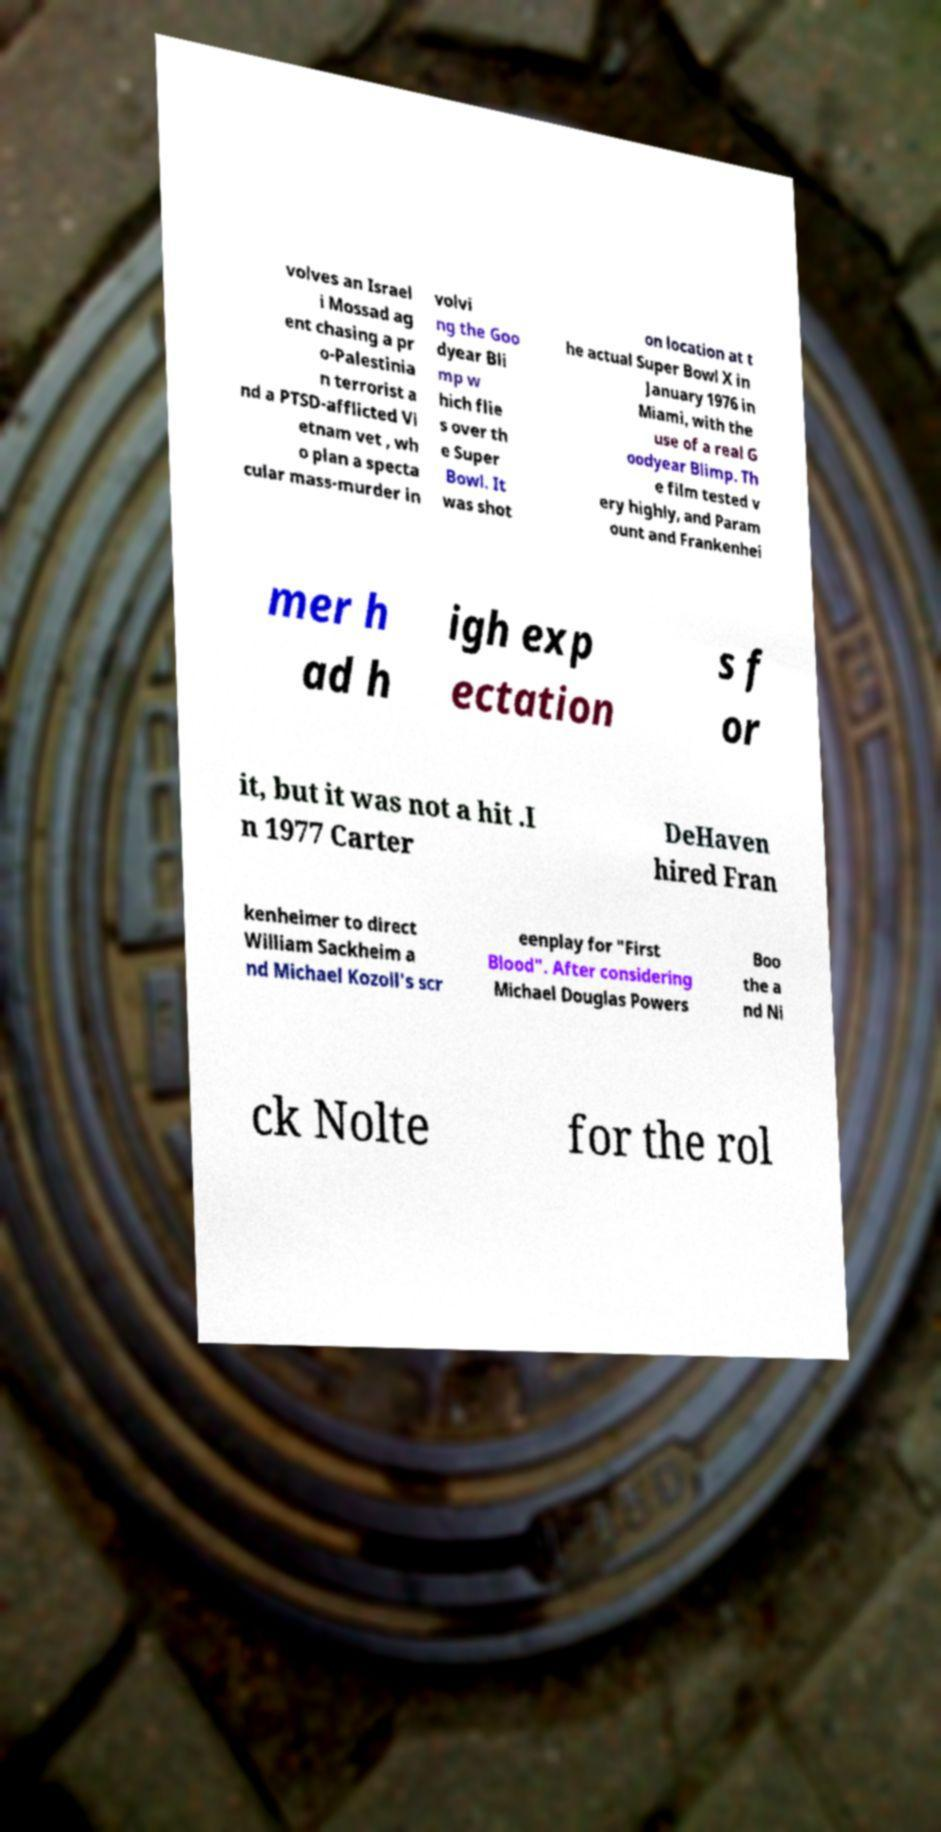Can you accurately transcribe the text from the provided image for me? volves an Israel i Mossad ag ent chasing a pr o-Palestinia n terrorist a nd a PTSD-afflicted Vi etnam vet , wh o plan a specta cular mass-murder in volvi ng the Goo dyear Bli mp w hich flie s over th e Super Bowl. It was shot on location at t he actual Super Bowl X in January 1976 in Miami, with the use of a real G oodyear Blimp. Th e film tested v ery highly, and Param ount and Frankenhei mer h ad h igh exp ectation s f or it, but it was not a hit .I n 1977 Carter DeHaven hired Fran kenheimer to direct William Sackheim a nd Michael Kozoll's scr eenplay for "First Blood". After considering Michael Douglas Powers Boo the a nd Ni ck Nolte for the rol 